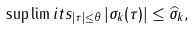<formula> <loc_0><loc_0><loc_500><loc_500>\sup \lim i t s _ { | \tau | \leq \theta } \left | \sigma _ { k } ( \tau ) \right | \leq \widehat { \sigma } _ { k } ,</formula> 